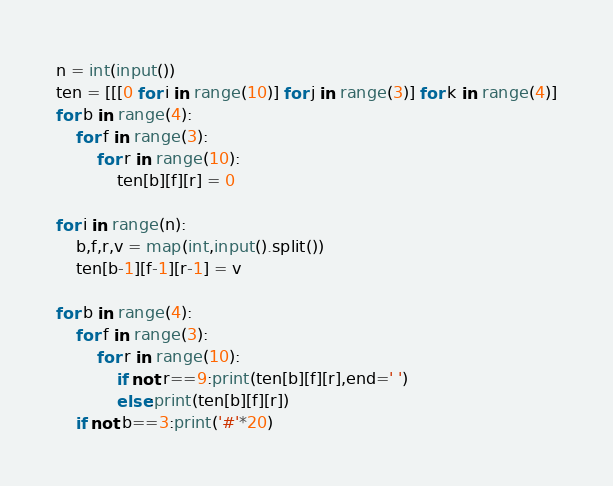<code> <loc_0><loc_0><loc_500><loc_500><_Python_>n = int(input())
ten = [[[0 for i in range(10)] for j in range(3)] for k in range(4)]
for b in range(4):
    for f in range(3):
        for r in range(10):
            ten[b][f][r] = 0

for i in range(n):
    b,f,r,v = map(int,input().split())
    ten[b-1][f-1][r-1] = v

for b in range(4):
    for f in range(3):
        for r in range(10):
            if not r==9:print(ten[b][f][r],end=' ')
            else:print(ten[b][f][r])
    if not b==3:print('#'*20)

</code> 